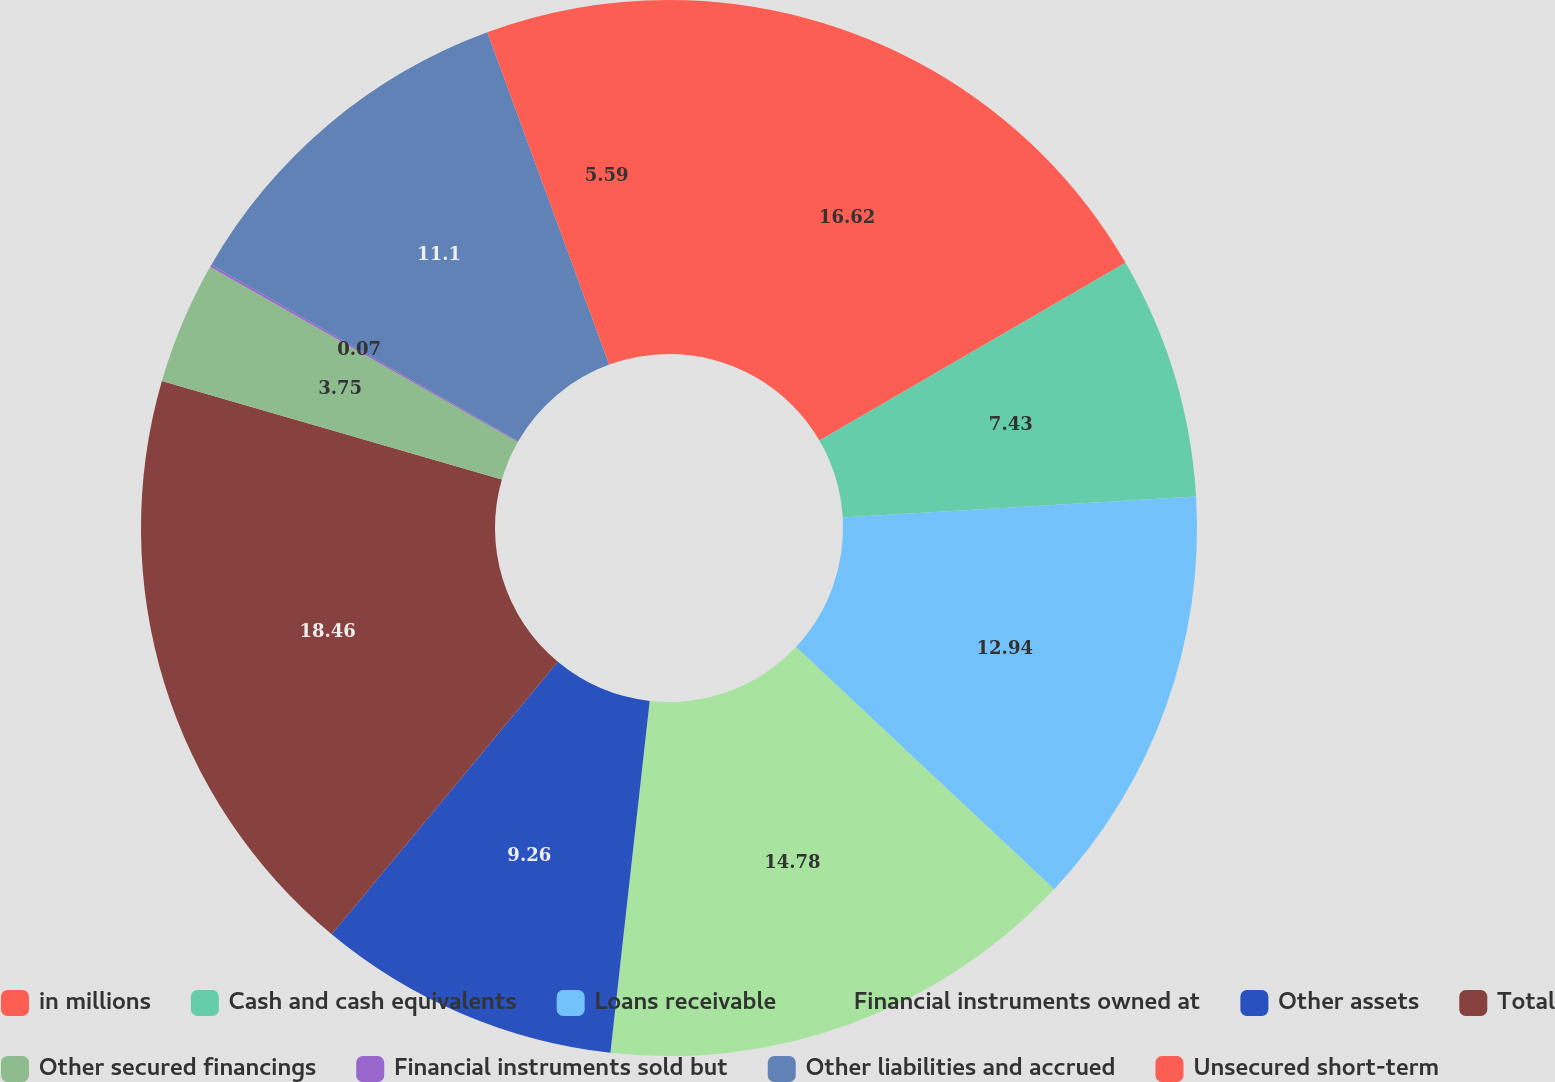<chart> <loc_0><loc_0><loc_500><loc_500><pie_chart><fcel>in millions<fcel>Cash and cash equivalents<fcel>Loans receivable<fcel>Financial instruments owned at<fcel>Other assets<fcel>Total<fcel>Other secured financings<fcel>Financial instruments sold but<fcel>Other liabilities and accrued<fcel>Unsecured short-term<nl><fcel>16.62%<fcel>7.43%<fcel>12.94%<fcel>14.78%<fcel>9.26%<fcel>18.46%<fcel>3.75%<fcel>0.07%<fcel>11.1%<fcel>5.59%<nl></chart> 